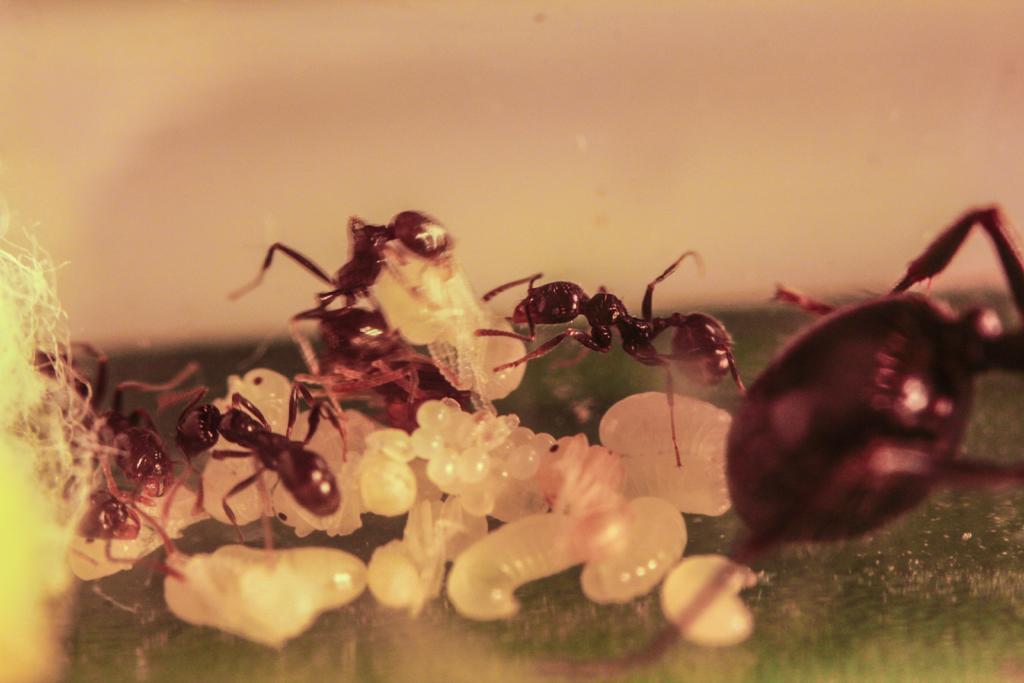Please provide a concise description of this image. In the picture we can see a green, colorless substance on it, we can see some ants, which are black in color and some eggs and in the background we can see a cream color background. 